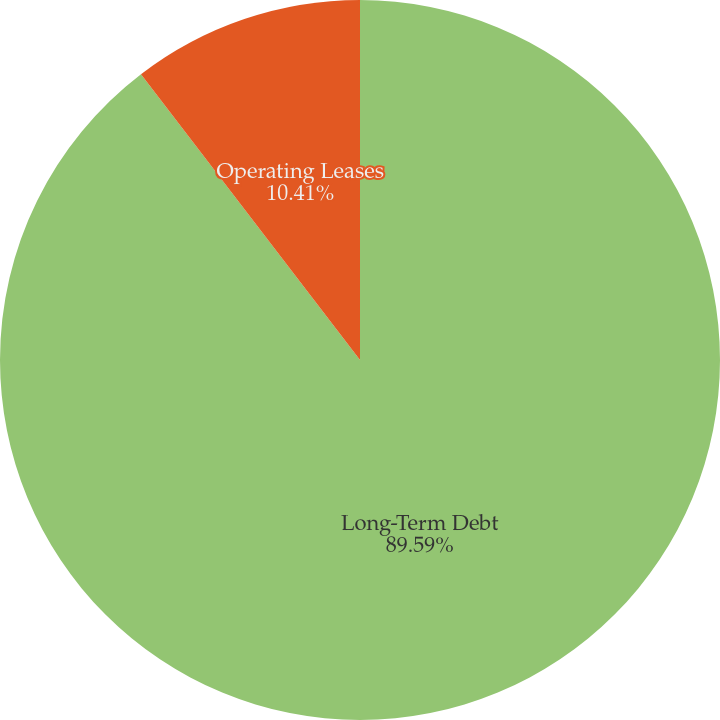<chart> <loc_0><loc_0><loc_500><loc_500><pie_chart><fcel>Long-Term Debt<fcel>Operating Leases<nl><fcel>89.59%<fcel>10.41%<nl></chart> 